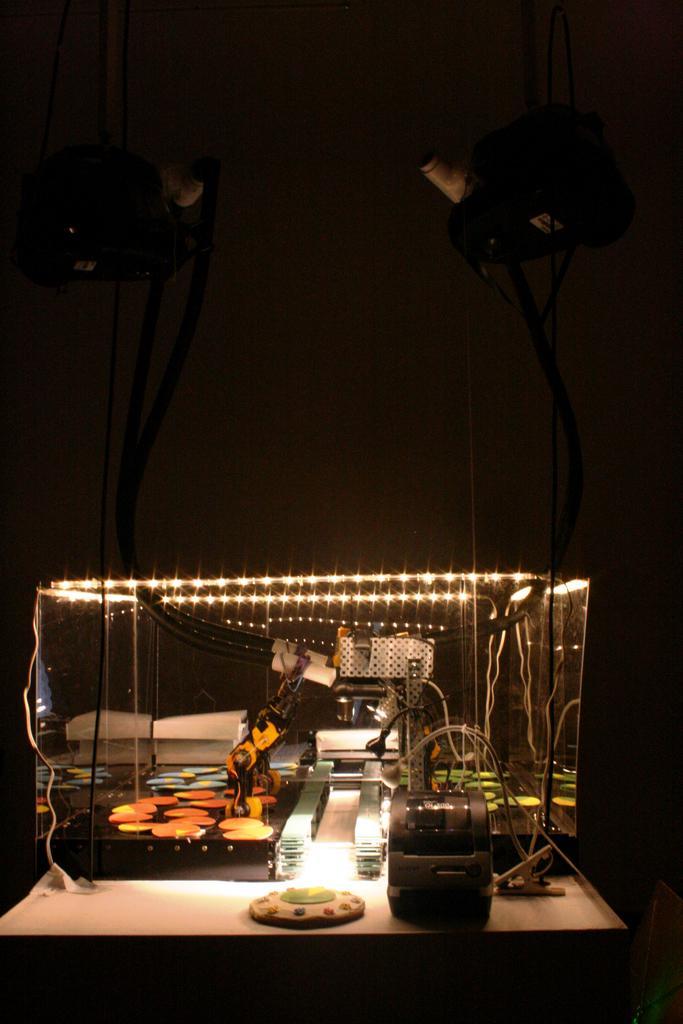How would you summarize this image in a sentence or two? In this picture we can see a glass display box. Inside the box, there are cables, lights and some objects. At the top of the image, there are two other objects and a dark background. 